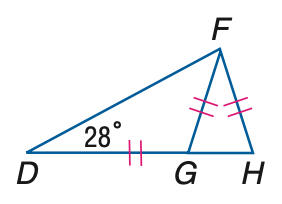Answer the mathemtical geometry problem and directly provide the correct option letter.
Question: \triangle D F G and \triangle F G H are isosceles, m \angle F D H = 28 and D G \cong F G \cong F H. Find the measure of \angle G F H.
Choices: A: 62 B: 64 C: 66 D: 68 D 